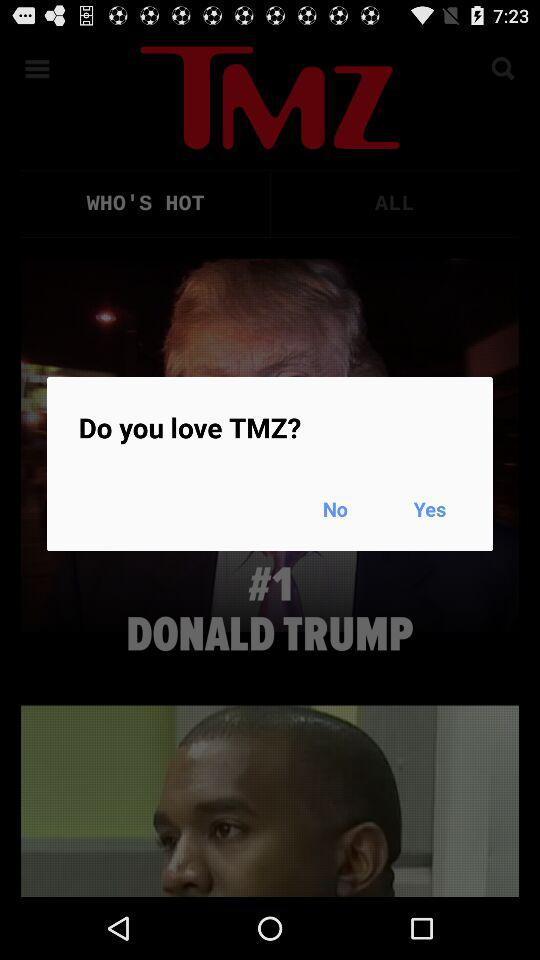What is the name of the application? The name of the application is "TMZ". 